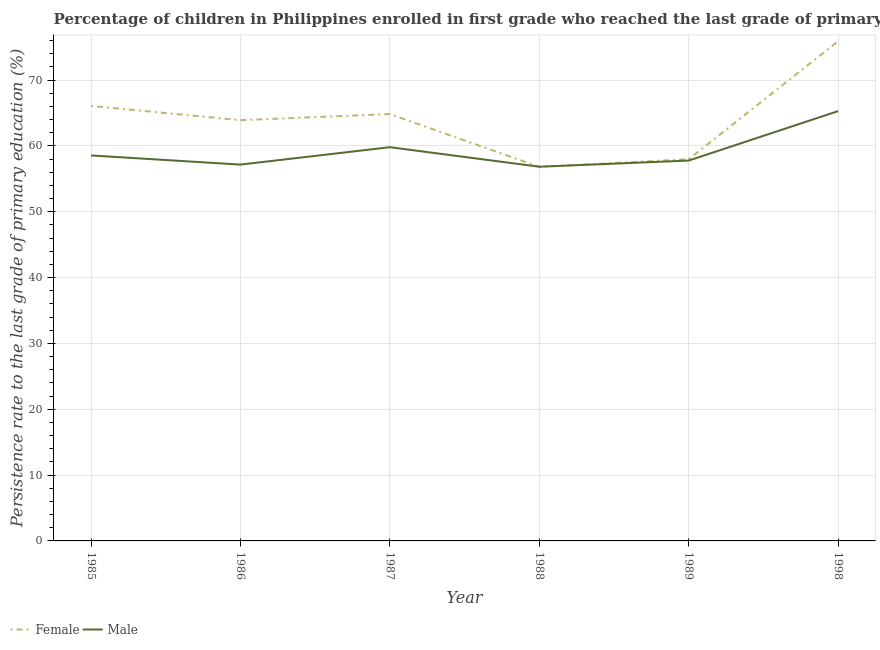How many different coloured lines are there?
Your response must be concise. 2. Does the line corresponding to persistence rate of male students intersect with the line corresponding to persistence rate of female students?
Your answer should be very brief. Yes. What is the persistence rate of male students in 1989?
Ensure brevity in your answer.  57.78. Across all years, what is the maximum persistence rate of male students?
Your answer should be very brief. 65.29. Across all years, what is the minimum persistence rate of female students?
Ensure brevity in your answer.  56.82. In which year was the persistence rate of male students maximum?
Keep it short and to the point. 1998. In which year was the persistence rate of female students minimum?
Keep it short and to the point. 1988. What is the total persistence rate of male students in the graph?
Your answer should be very brief. 355.42. What is the difference between the persistence rate of female students in 1986 and that in 1988?
Your response must be concise. 7.09. What is the difference between the persistence rate of female students in 1988 and the persistence rate of male students in 1985?
Provide a succinct answer. -1.73. What is the average persistence rate of male students per year?
Keep it short and to the point. 59.24. In the year 1985, what is the difference between the persistence rate of female students and persistence rate of male students?
Keep it short and to the point. 7.52. In how many years, is the persistence rate of female students greater than 46 %?
Your answer should be very brief. 6. What is the ratio of the persistence rate of male students in 1985 to that in 1987?
Give a very brief answer. 0.98. Is the persistence rate of female students in 1987 less than that in 1988?
Your answer should be very brief. No. What is the difference between the highest and the second highest persistence rate of male students?
Make the answer very short. 5.48. What is the difference between the highest and the lowest persistence rate of male students?
Your answer should be compact. 8.45. In how many years, is the persistence rate of female students greater than the average persistence rate of female students taken over all years?
Your response must be concise. 3. Is the sum of the persistence rate of male students in 1985 and 1988 greater than the maximum persistence rate of female students across all years?
Ensure brevity in your answer.  Yes. Does the persistence rate of male students monotonically increase over the years?
Your answer should be compact. No. Is the persistence rate of female students strictly greater than the persistence rate of male students over the years?
Offer a terse response. No. What is the difference between two consecutive major ticks on the Y-axis?
Give a very brief answer. 10. Does the graph contain any zero values?
Your answer should be compact. No. Where does the legend appear in the graph?
Your response must be concise. Bottom left. How many legend labels are there?
Your answer should be compact. 2. How are the legend labels stacked?
Give a very brief answer. Horizontal. What is the title of the graph?
Provide a short and direct response. Percentage of children in Philippines enrolled in first grade who reached the last grade of primary education. What is the label or title of the Y-axis?
Keep it short and to the point. Persistence rate to the last grade of primary education (%). What is the Persistence rate to the last grade of primary education (%) of Female in 1985?
Offer a very short reply. 66.07. What is the Persistence rate to the last grade of primary education (%) of Male in 1985?
Your answer should be compact. 58.55. What is the Persistence rate to the last grade of primary education (%) in Female in 1986?
Offer a terse response. 63.91. What is the Persistence rate to the last grade of primary education (%) of Male in 1986?
Make the answer very short. 57.16. What is the Persistence rate to the last grade of primary education (%) in Female in 1987?
Your answer should be very brief. 64.84. What is the Persistence rate to the last grade of primary education (%) of Male in 1987?
Your answer should be very brief. 59.81. What is the Persistence rate to the last grade of primary education (%) in Female in 1988?
Offer a very short reply. 56.82. What is the Persistence rate to the last grade of primary education (%) in Male in 1988?
Provide a succinct answer. 56.84. What is the Persistence rate to the last grade of primary education (%) of Female in 1989?
Provide a short and direct response. 57.98. What is the Persistence rate to the last grade of primary education (%) of Male in 1989?
Keep it short and to the point. 57.78. What is the Persistence rate to the last grade of primary education (%) of Female in 1998?
Offer a very short reply. 75.91. What is the Persistence rate to the last grade of primary education (%) of Male in 1998?
Your answer should be very brief. 65.29. Across all years, what is the maximum Persistence rate to the last grade of primary education (%) in Female?
Offer a terse response. 75.91. Across all years, what is the maximum Persistence rate to the last grade of primary education (%) in Male?
Your answer should be compact. 65.29. Across all years, what is the minimum Persistence rate to the last grade of primary education (%) in Female?
Provide a succinct answer. 56.82. Across all years, what is the minimum Persistence rate to the last grade of primary education (%) in Male?
Keep it short and to the point. 56.84. What is the total Persistence rate to the last grade of primary education (%) of Female in the graph?
Your answer should be very brief. 385.53. What is the total Persistence rate to the last grade of primary education (%) in Male in the graph?
Give a very brief answer. 355.42. What is the difference between the Persistence rate to the last grade of primary education (%) of Female in 1985 and that in 1986?
Your answer should be compact. 2.16. What is the difference between the Persistence rate to the last grade of primary education (%) of Male in 1985 and that in 1986?
Offer a terse response. 1.39. What is the difference between the Persistence rate to the last grade of primary education (%) of Female in 1985 and that in 1987?
Make the answer very short. 1.24. What is the difference between the Persistence rate to the last grade of primary education (%) in Male in 1985 and that in 1987?
Your answer should be very brief. -1.26. What is the difference between the Persistence rate to the last grade of primary education (%) in Female in 1985 and that in 1988?
Provide a short and direct response. 9.26. What is the difference between the Persistence rate to the last grade of primary education (%) of Male in 1985 and that in 1988?
Your response must be concise. 1.71. What is the difference between the Persistence rate to the last grade of primary education (%) of Female in 1985 and that in 1989?
Your answer should be very brief. 8.09. What is the difference between the Persistence rate to the last grade of primary education (%) in Male in 1985 and that in 1989?
Offer a very short reply. 0.78. What is the difference between the Persistence rate to the last grade of primary education (%) of Female in 1985 and that in 1998?
Provide a short and direct response. -9.84. What is the difference between the Persistence rate to the last grade of primary education (%) in Male in 1985 and that in 1998?
Your response must be concise. -6.74. What is the difference between the Persistence rate to the last grade of primary education (%) of Female in 1986 and that in 1987?
Offer a very short reply. -0.93. What is the difference between the Persistence rate to the last grade of primary education (%) of Male in 1986 and that in 1987?
Ensure brevity in your answer.  -2.64. What is the difference between the Persistence rate to the last grade of primary education (%) in Female in 1986 and that in 1988?
Your answer should be very brief. 7.09. What is the difference between the Persistence rate to the last grade of primary education (%) of Male in 1986 and that in 1988?
Keep it short and to the point. 0.32. What is the difference between the Persistence rate to the last grade of primary education (%) of Female in 1986 and that in 1989?
Give a very brief answer. 5.93. What is the difference between the Persistence rate to the last grade of primary education (%) in Male in 1986 and that in 1989?
Offer a very short reply. -0.61. What is the difference between the Persistence rate to the last grade of primary education (%) in Female in 1986 and that in 1998?
Keep it short and to the point. -12. What is the difference between the Persistence rate to the last grade of primary education (%) of Male in 1986 and that in 1998?
Give a very brief answer. -8.12. What is the difference between the Persistence rate to the last grade of primary education (%) in Female in 1987 and that in 1988?
Your answer should be compact. 8.02. What is the difference between the Persistence rate to the last grade of primary education (%) of Male in 1987 and that in 1988?
Your response must be concise. 2.97. What is the difference between the Persistence rate to the last grade of primary education (%) of Female in 1987 and that in 1989?
Your response must be concise. 6.85. What is the difference between the Persistence rate to the last grade of primary education (%) in Male in 1987 and that in 1989?
Provide a short and direct response. 2.03. What is the difference between the Persistence rate to the last grade of primary education (%) of Female in 1987 and that in 1998?
Keep it short and to the point. -11.07. What is the difference between the Persistence rate to the last grade of primary education (%) of Male in 1987 and that in 1998?
Provide a succinct answer. -5.48. What is the difference between the Persistence rate to the last grade of primary education (%) of Female in 1988 and that in 1989?
Your response must be concise. -1.17. What is the difference between the Persistence rate to the last grade of primary education (%) of Male in 1988 and that in 1989?
Keep it short and to the point. -0.93. What is the difference between the Persistence rate to the last grade of primary education (%) in Female in 1988 and that in 1998?
Your answer should be compact. -19.1. What is the difference between the Persistence rate to the last grade of primary education (%) in Male in 1988 and that in 1998?
Provide a short and direct response. -8.45. What is the difference between the Persistence rate to the last grade of primary education (%) in Female in 1989 and that in 1998?
Offer a very short reply. -17.93. What is the difference between the Persistence rate to the last grade of primary education (%) in Male in 1989 and that in 1998?
Make the answer very short. -7.51. What is the difference between the Persistence rate to the last grade of primary education (%) of Female in 1985 and the Persistence rate to the last grade of primary education (%) of Male in 1986?
Your answer should be very brief. 8.91. What is the difference between the Persistence rate to the last grade of primary education (%) in Female in 1985 and the Persistence rate to the last grade of primary education (%) in Male in 1987?
Keep it short and to the point. 6.27. What is the difference between the Persistence rate to the last grade of primary education (%) of Female in 1985 and the Persistence rate to the last grade of primary education (%) of Male in 1988?
Offer a very short reply. 9.23. What is the difference between the Persistence rate to the last grade of primary education (%) in Female in 1985 and the Persistence rate to the last grade of primary education (%) in Male in 1989?
Ensure brevity in your answer.  8.3. What is the difference between the Persistence rate to the last grade of primary education (%) of Female in 1985 and the Persistence rate to the last grade of primary education (%) of Male in 1998?
Your answer should be compact. 0.79. What is the difference between the Persistence rate to the last grade of primary education (%) in Female in 1986 and the Persistence rate to the last grade of primary education (%) in Male in 1987?
Provide a short and direct response. 4.1. What is the difference between the Persistence rate to the last grade of primary education (%) in Female in 1986 and the Persistence rate to the last grade of primary education (%) in Male in 1988?
Keep it short and to the point. 7.07. What is the difference between the Persistence rate to the last grade of primary education (%) of Female in 1986 and the Persistence rate to the last grade of primary education (%) of Male in 1989?
Keep it short and to the point. 6.13. What is the difference between the Persistence rate to the last grade of primary education (%) of Female in 1986 and the Persistence rate to the last grade of primary education (%) of Male in 1998?
Your response must be concise. -1.38. What is the difference between the Persistence rate to the last grade of primary education (%) of Female in 1987 and the Persistence rate to the last grade of primary education (%) of Male in 1988?
Provide a succinct answer. 8. What is the difference between the Persistence rate to the last grade of primary education (%) of Female in 1987 and the Persistence rate to the last grade of primary education (%) of Male in 1989?
Offer a very short reply. 7.06. What is the difference between the Persistence rate to the last grade of primary education (%) in Female in 1987 and the Persistence rate to the last grade of primary education (%) in Male in 1998?
Make the answer very short. -0.45. What is the difference between the Persistence rate to the last grade of primary education (%) in Female in 1988 and the Persistence rate to the last grade of primary education (%) in Male in 1989?
Your answer should be very brief. -0.96. What is the difference between the Persistence rate to the last grade of primary education (%) in Female in 1988 and the Persistence rate to the last grade of primary education (%) in Male in 1998?
Offer a terse response. -8.47. What is the difference between the Persistence rate to the last grade of primary education (%) of Female in 1989 and the Persistence rate to the last grade of primary education (%) of Male in 1998?
Provide a short and direct response. -7.3. What is the average Persistence rate to the last grade of primary education (%) in Female per year?
Your response must be concise. 64.26. What is the average Persistence rate to the last grade of primary education (%) in Male per year?
Give a very brief answer. 59.24. In the year 1985, what is the difference between the Persistence rate to the last grade of primary education (%) of Female and Persistence rate to the last grade of primary education (%) of Male?
Your answer should be very brief. 7.52. In the year 1986, what is the difference between the Persistence rate to the last grade of primary education (%) of Female and Persistence rate to the last grade of primary education (%) of Male?
Offer a very short reply. 6.75. In the year 1987, what is the difference between the Persistence rate to the last grade of primary education (%) of Female and Persistence rate to the last grade of primary education (%) of Male?
Ensure brevity in your answer.  5.03. In the year 1988, what is the difference between the Persistence rate to the last grade of primary education (%) in Female and Persistence rate to the last grade of primary education (%) in Male?
Offer a very short reply. -0.02. In the year 1989, what is the difference between the Persistence rate to the last grade of primary education (%) of Female and Persistence rate to the last grade of primary education (%) of Male?
Offer a terse response. 0.21. In the year 1998, what is the difference between the Persistence rate to the last grade of primary education (%) in Female and Persistence rate to the last grade of primary education (%) in Male?
Your response must be concise. 10.62. What is the ratio of the Persistence rate to the last grade of primary education (%) in Female in 1985 to that in 1986?
Provide a succinct answer. 1.03. What is the ratio of the Persistence rate to the last grade of primary education (%) in Male in 1985 to that in 1986?
Your answer should be very brief. 1.02. What is the ratio of the Persistence rate to the last grade of primary education (%) of Female in 1985 to that in 1987?
Provide a succinct answer. 1.02. What is the ratio of the Persistence rate to the last grade of primary education (%) of Male in 1985 to that in 1987?
Keep it short and to the point. 0.98. What is the ratio of the Persistence rate to the last grade of primary education (%) of Female in 1985 to that in 1988?
Offer a terse response. 1.16. What is the ratio of the Persistence rate to the last grade of primary education (%) in Male in 1985 to that in 1988?
Offer a very short reply. 1.03. What is the ratio of the Persistence rate to the last grade of primary education (%) of Female in 1985 to that in 1989?
Your answer should be compact. 1.14. What is the ratio of the Persistence rate to the last grade of primary education (%) of Male in 1985 to that in 1989?
Offer a very short reply. 1.01. What is the ratio of the Persistence rate to the last grade of primary education (%) of Female in 1985 to that in 1998?
Offer a terse response. 0.87. What is the ratio of the Persistence rate to the last grade of primary education (%) of Male in 1985 to that in 1998?
Your response must be concise. 0.9. What is the ratio of the Persistence rate to the last grade of primary education (%) in Female in 1986 to that in 1987?
Provide a succinct answer. 0.99. What is the ratio of the Persistence rate to the last grade of primary education (%) in Male in 1986 to that in 1987?
Ensure brevity in your answer.  0.96. What is the ratio of the Persistence rate to the last grade of primary education (%) of Female in 1986 to that in 1988?
Ensure brevity in your answer.  1.12. What is the ratio of the Persistence rate to the last grade of primary education (%) of Female in 1986 to that in 1989?
Offer a very short reply. 1.1. What is the ratio of the Persistence rate to the last grade of primary education (%) of Female in 1986 to that in 1998?
Provide a succinct answer. 0.84. What is the ratio of the Persistence rate to the last grade of primary education (%) of Male in 1986 to that in 1998?
Make the answer very short. 0.88. What is the ratio of the Persistence rate to the last grade of primary education (%) in Female in 1987 to that in 1988?
Give a very brief answer. 1.14. What is the ratio of the Persistence rate to the last grade of primary education (%) of Male in 1987 to that in 1988?
Offer a very short reply. 1.05. What is the ratio of the Persistence rate to the last grade of primary education (%) of Female in 1987 to that in 1989?
Offer a very short reply. 1.12. What is the ratio of the Persistence rate to the last grade of primary education (%) of Male in 1987 to that in 1989?
Provide a short and direct response. 1.04. What is the ratio of the Persistence rate to the last grade of primary education (%) in Female in 1987 to that in 1998?
Keep it short and to the point. 0.85. What is the ratio of the Persistence rate to the last grade of primary education (%) of Male in 1987 to that in 1998?
Your answer should be compact. 0.92. What is the ratio of the Persistence rate to the last grade of primary education (%) of Female in 1988 to that in 1989?
Ensure brevity in your answer.  0.98. What is the ratio of the Persistence rate to the last grade of primary education (%) in Male in 1988 to that in 1989?
Ensure brevity in your answer.  0.98. What is the ratio of the Persistence rate to the last grade of primary education (%) of Female in 1988 to that in 1998?
Give a very brief answer. 0.75. What is the ratio of the Persistence rate to the last grade of primary education (%) of Male in 1988 to that in 1998?
Provide a succinct answer. 0.87. What is the ratio of the Persistence rate to the last grade of primary education (%) of Female in 1989 to that in 1998?
Offer a terse response. 0.76. What is the ratio of the Persistence rate to the last grade of primary education (%) of Male in 1989 to that in 1998?
Provide a succinct answer. 0.88. What is the difference between the highest and the second highest Persistence rate to the last grade of primary education (%) in Female?
Provide a succinct answer. 9.84. What is the difference between the highest and the second highest Persistence rate to the last grade of primary education (%) in Male?
Offer a very short reply. 5.48. What is the difference between the highest and the lowest Persistence rate to the last grade of primary education (%) in Female?
Offer a very short reply. 19.1. What is the difference between the highest and the lowest Persistence rate to the last grade of primary education (%) in Male?
Give a very brief answer. 8.45. 